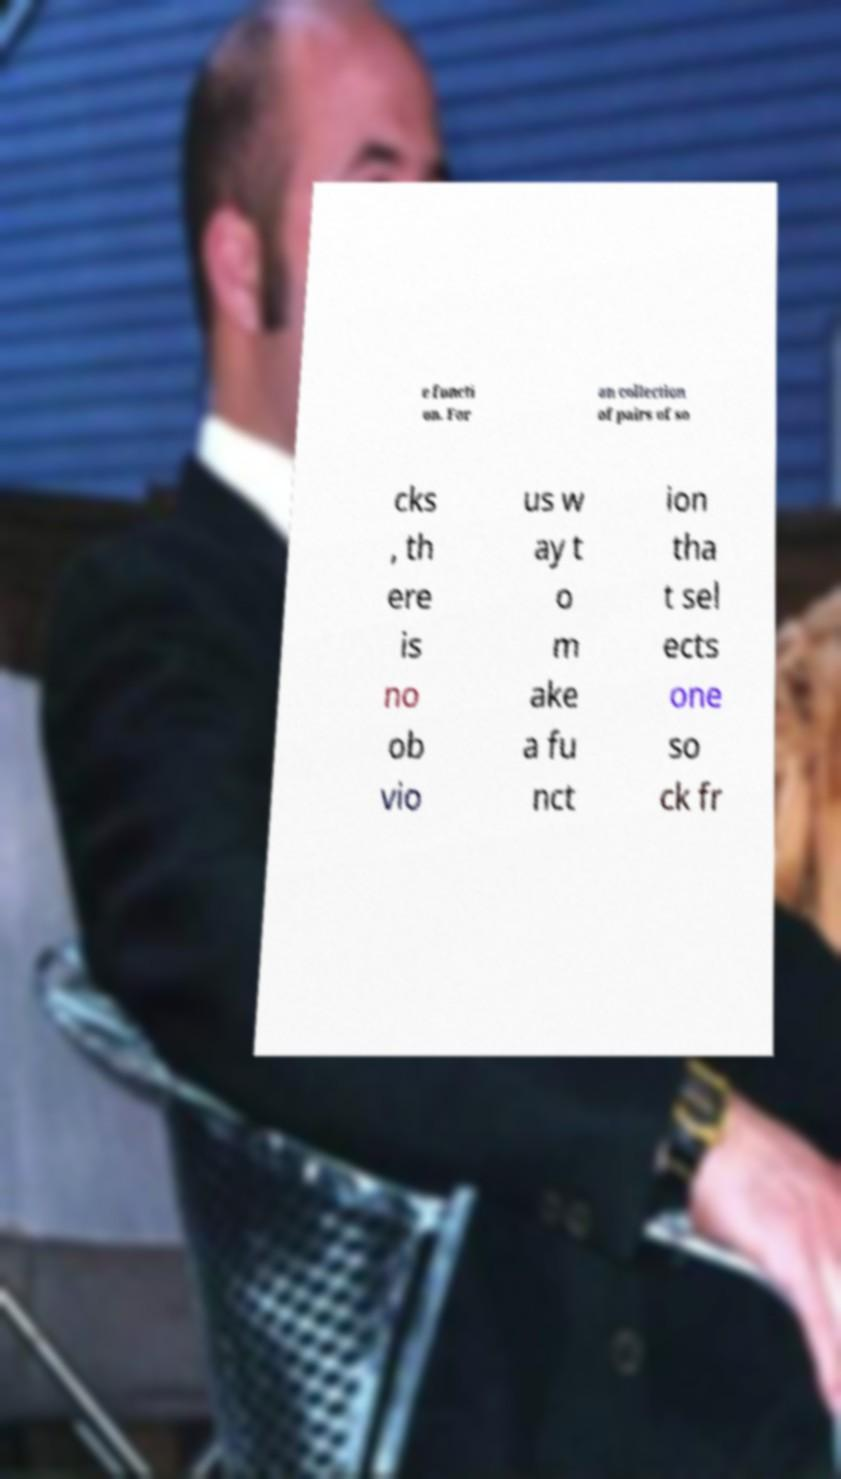Please read and relay the text visible in this image. What does it say? e functi on. For an collection of pairs of so cks , th ere is no ob vio us w ay t o m ake a fu nct ion tha t sel ects one so ck fr 